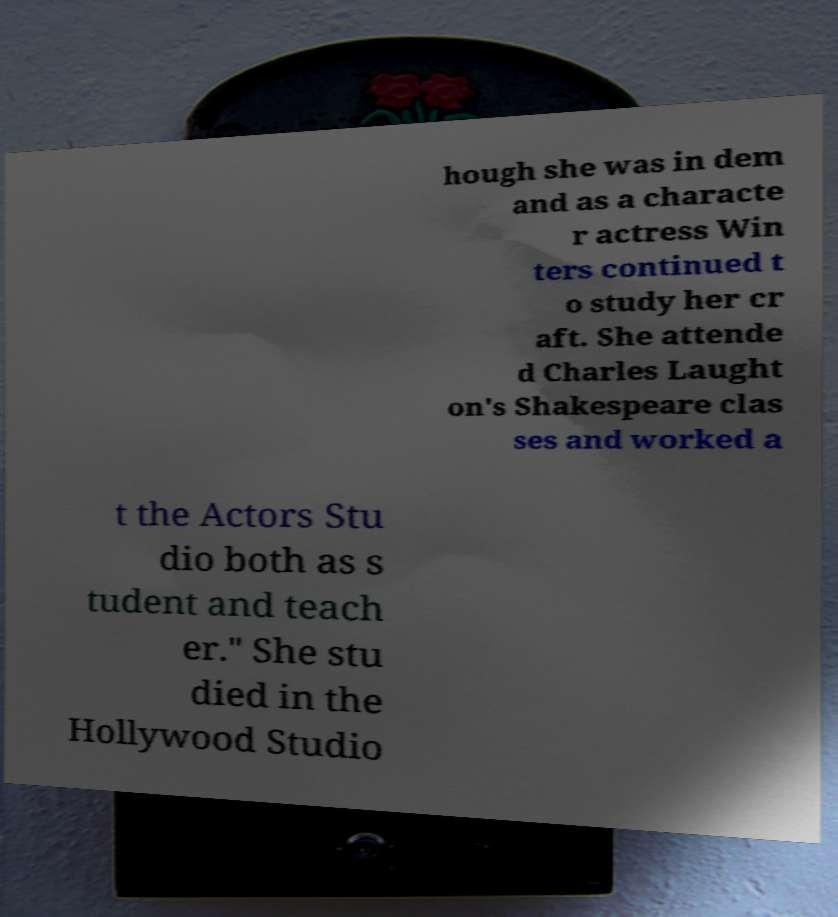Could you extract and type out the text from this image? hough she was in dem and as a characte r actress Win ters continued t o study her cr aft. She attende d Charles Laught on's Shakespeare clas ses and worked a t the Actors Stu dio both as s tudent and teach er." She stu died in the Hollywood Studio 